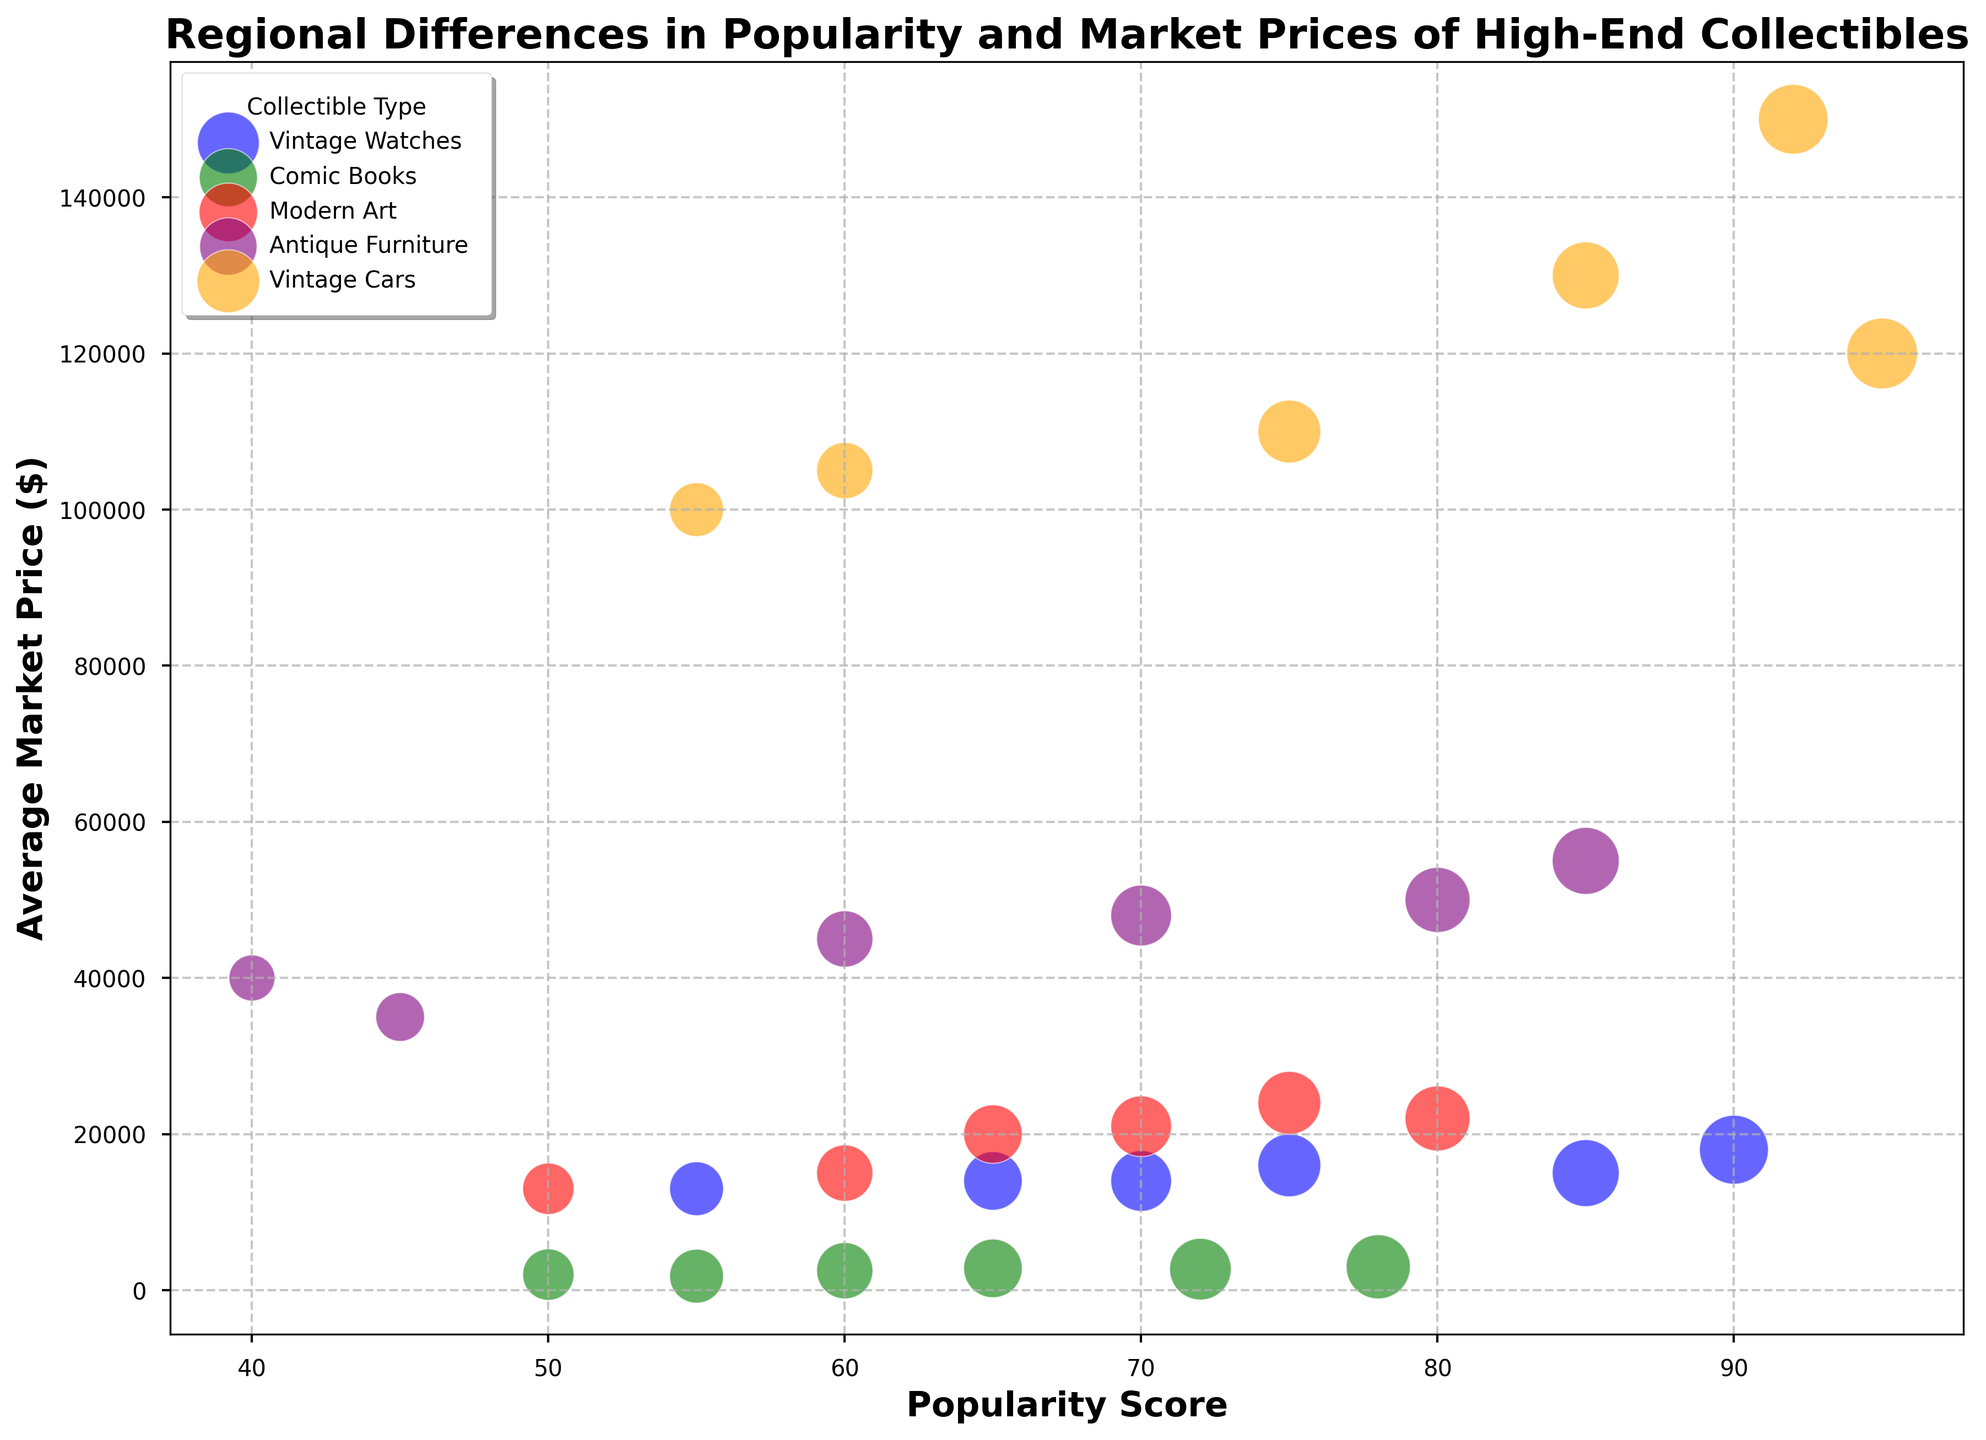What's the most popular collectible type in Europe? We need to find the data points corresponding to Europe. The highest popularity score among them is for Vintage Watches with a score of 90.
Answer: Vintage Watches Which region has the highest average market price for Comic Books? Comic Books are indicated by green bubbles. By comparing the market prices visually, North America leads with a price of $3000.
Answer: North America Which collectible type generally shows higher popularity scores, Antique Furniture or Modern Art? Antique Furniture and Modern Art are represented by purple and red bubbles, respectively. By visual assessment, purple bubbles, for the most part, appear to have larger sizes indicating strictly higher popularity scores.
Answer: Antique Furniture What is the price difference between the highest priced Modern Art in Europe and the lowest priced Modern Art in Africa? The highest priced Modern Art in Europe is $22000, and the lowest priced Modern Art in Africa is $13000. The difference is $22000 - $13000 = $9000.
Answer: $9000 Which region shows a medium level of cultural significance for Vintage Watches? Vintage Watches are blue, and the medium level of cultural significance is indicated for Asia and Africa with these collectibles.
Answer: Asia and Africa What is the total popularity score for Comic Books across all regions? We need to sum the popularity scores for Comic Books across all regions: 78 (North America) + 60 (Europe) + 50 (Asia) + 72 (South America) + 55 (Africa) + 65 (Australia) = 380.
Answer: 380 Do any collectible types have equal average market prices in any regions? By visually comparing bubble positions along the price axis, we see that no two bubbles align perfectly at the same market price level for different regions across any collectible type.
Answer: No Between South America and Australia, which region has higher popularity scores for Modern Art? Modern Art is represented by red bubbles. Visually comparing the sizes, Australia's red bubble appears larger (70) than South America's (60).
Answer: Australia Which region shows a higher price for Antique Furniture, North America or Australia? By comparing the positions of the purple bubbles for North America and Australia on the price axis, North America's bubble appears higher (50,000) than Australia's (48,000).
Answer: North America For Europe, which collectible type has the lowest popularity score? For Europe, we compare the sizes of bubbles across different colors for each type, and Comic Books (green) have the lowest score at 60.
Answer: Comic Books 